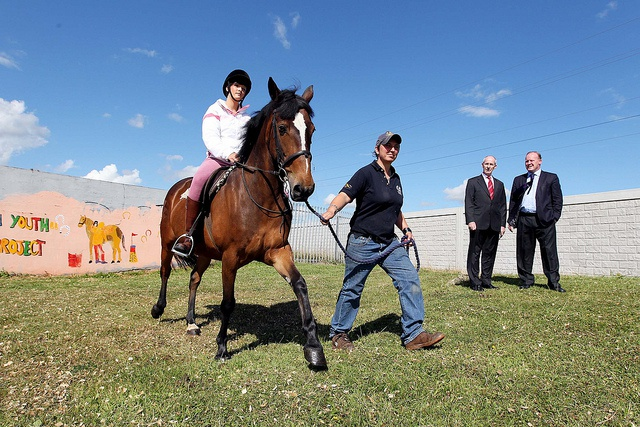Describe the objects in this image and their specific colors. I can see horse in gray, black, maroon, and brown tones, people in gray and black tones, people in gray, black, and lavender tones, people in gray, black, and lightgray tones, and people in gray, white, black, lightpink, and maroon tones in this image. 